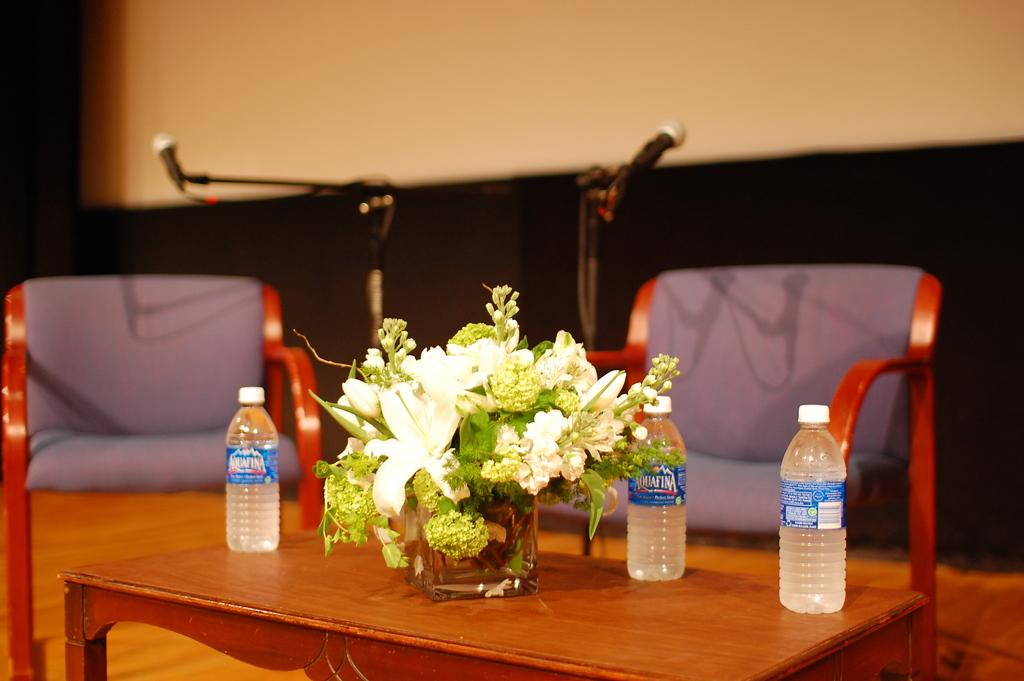What object can be seen in the image that is typically used for holding plants? There is a flower pot in the image. How many bottles are on the table in the image? There are three bottles on a table in the image. What type of furniture is visible in the background of the image? There are two chairs in the background of the image. What objects are used for amplifying sound in the background of the image? There are two microphones in the background of the image. What is visible behind the main subjects in the image? There is a wall visible in the background of the image. What season is depicted in the image? The image does not depict a specific season; it only shows objects like a flower pot, bottles, chairs, and microphones. What type of prose can be heard being read aloud in the image? There is no indication of any prose being read aloud in the image; it only shows objects and furniture. 